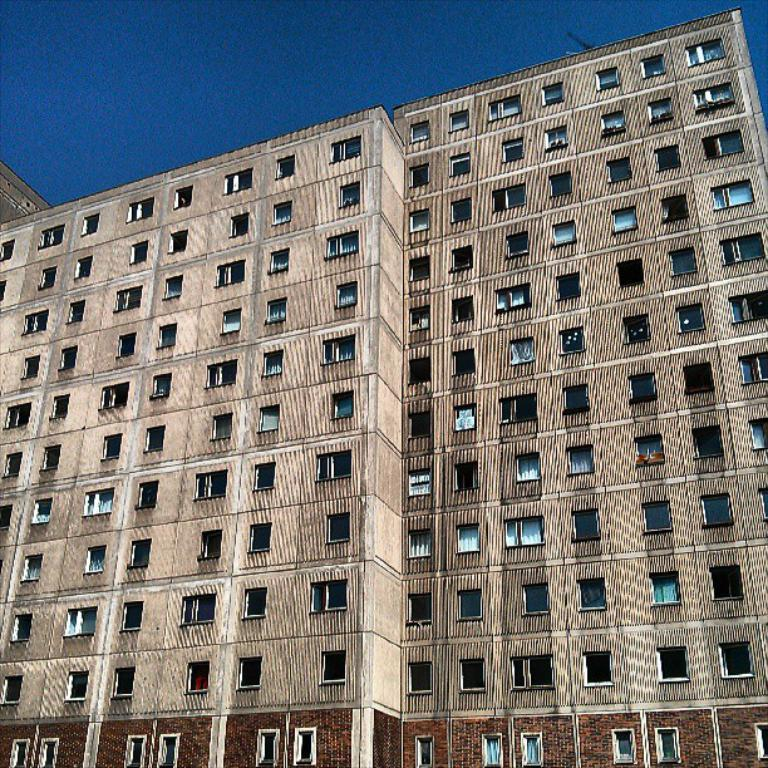What is the main subject in the picture? There is a building in the picture. What can be seen in the background of the picture? The sky is visible at the top of the picture. What type of windows does the building have? The building has glass windows. What type of rifle can be seen in the picture? There is no rifle present in the picture; it features a building with glass windows and a visible sky. What verse is being recited by the power lines in the picture? There are no power lines or any indication of a verse being recited in the picture. 